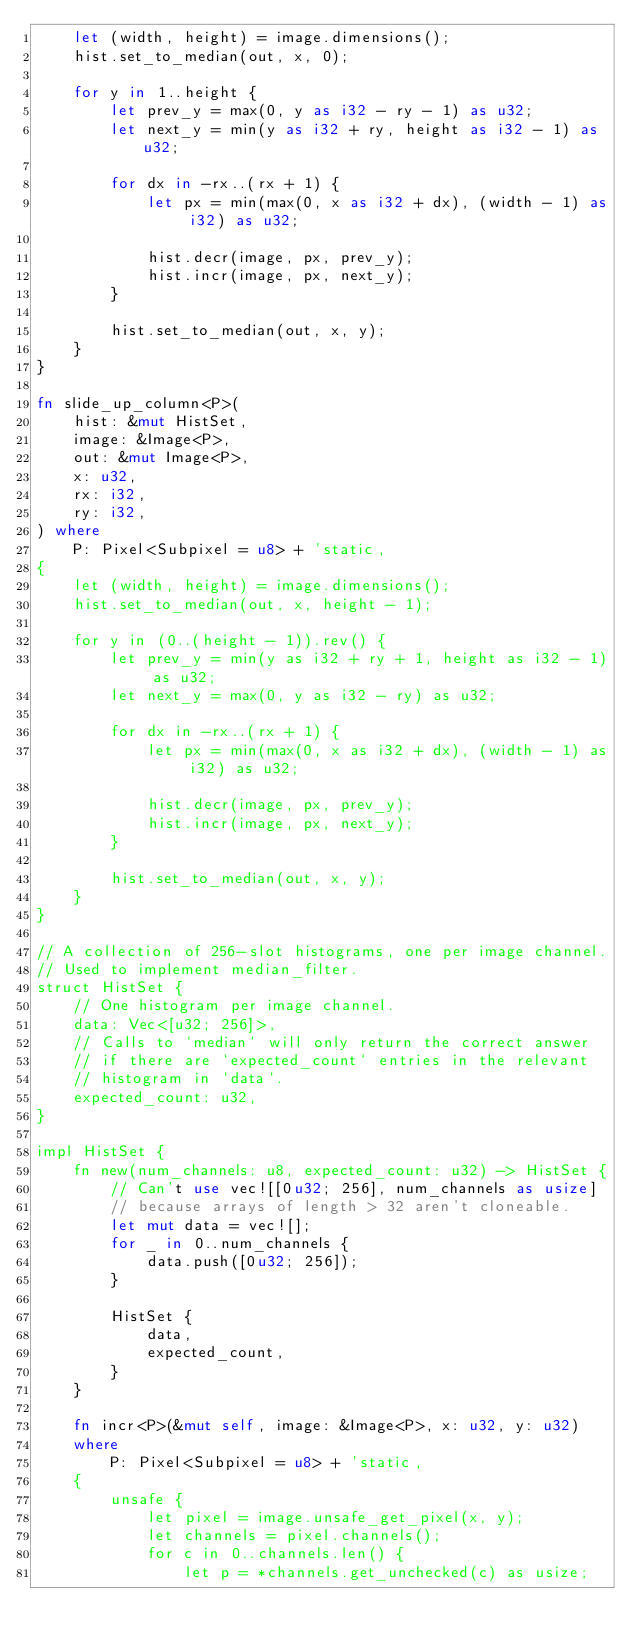<code> <loc_0><loc_0><loc_500><loc_500><_Rust_>    let (width, height) = image.dimensions();
    hist.set_to_median(out, x, 0);

    for y in 1..height {
        let prev_y = max(0, y as i32 - ry - 1) as u32;
        let next_y = min(y as i32 + ry, height as i32 - 1) as u32;

        for dx in -rx..(rx + 1) {
            let px = min(max(0, x as i32 + dx), (width - 1) as i32) as u32;

            hist.decr(image, px, prev_y);
            hist.incr(image, px, next_y);
        }

        hist.set_to_median(out, x, y);
    }
}

fn slide_up_column<P>(
    hist: &mut HistSet,
    image: &Image<P>,
    out: &mut Image<P>,
    x: u32,
    rx: i32,
    ry: i32,
) where
    P: Pixel<Subpixel = u8> + 'static,
{
    let (width, height) = image.dimensions();
    hist.set_to_median(out, x, height - 1);

    for y in (0..(height - 1)).rev() {
        let prev_y = min(y as i32 + ry + 1, height as i32 - 1) as u32;
        let next_y = max(0, y as i32 - ry) as u32;

        for dx in -rx..(rx + 1) {
            let px = min(max(0, x as i32 + dx), (width - 1) as i32) as u32;

            hist.decr(image, px, prev_y);
            hist.incr(image, px, next_y);
        }

        hist.set_to_median(out, x, y);
    }
}

// A collection of 256-slot histograms, one per image channel.
// Used to implement median_filter.
struct HistSet {
    // One histogram per image channel.
    data: Vec<[u32; 256]>,
    // Calls to `median` will only return the correct answer
    // if there are `expected_count` entries in the relevant
    // histogram in `data`.
    expected_count: u32,
}

impl HistSet {
    fn new(num_channels: u8, expected_count: u32) -> HistSet {
        // Can't use vec![[0u32; 256], num_channels as usize]
        // because arrays of length > 32 aren't cloneable.
        let mut data = vec![];
        for _ in 0..num_channels {
            data.push([0u32; 256]);
        }

        HistSet {
            data,
            expected_count,
        }
    }

    fn incr<P>(&mut self, image: &Image<P>, x: u32, y: u32)
    where
        P: Pixel<Subpixel = u8> + 'static,
    {
        unsafe {
            let pixel = image.unsafe_get_pixel(x, y);
            let channels = pixel.channels();
            for c in 0..channels.len() {
                let p = *channels.get_unchecked(c) as usize;</code> 